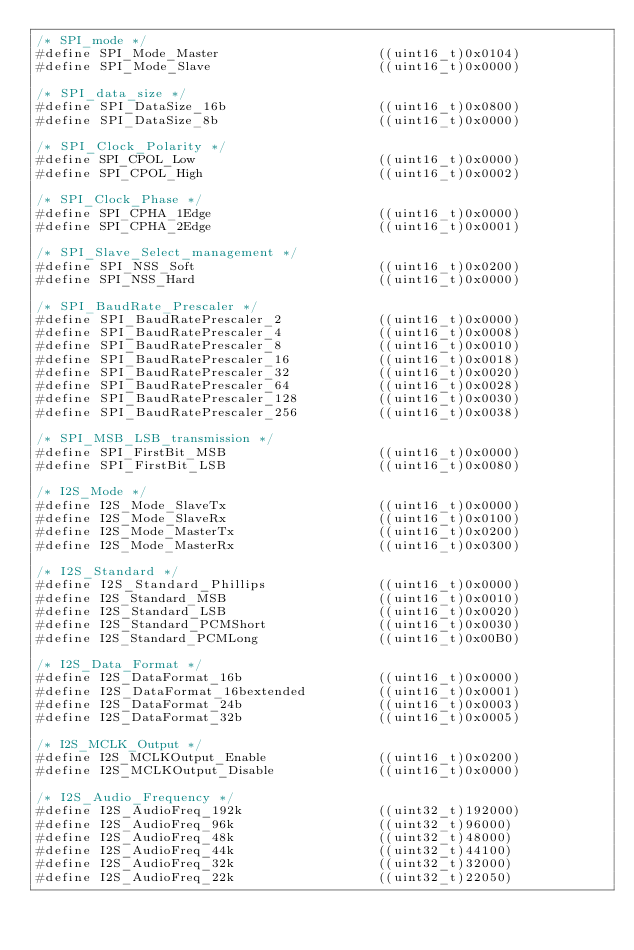<code> <loc_0><loc_0><loc_500><loc_500><_C_>/* SPI_mode */
#define SPI_Mode_Master                    ((uint16_t)0x0104)
#define SPI_Mode_Slave                     ((uint16_t)0x0000)

/* SPI_data_size */
#define SPI_DataSize_16b                   ((uint16_t)0x0800)
#define SPI_DataSize_8b                    ((uint16_t)0x0000)

/* SPI_Clock_Polarity */
#define SPI_CPOL_Low                       ((uint16_t)0x0000)
#define SPI_CPOL_High                      ((uint16_t)0x0002)

/* SPI_Clock_Phase */
#define SPI_CPHA_1Edge                     ((uint16_t)0x0000)
#define SPI_CPHA_2Edge                     ((uint16_t)0x0001)

/* SPI_Slave_Select_management */
#define SPI_NSS_Soft                       ((uint16_t)0x0200)
#define SPI_NSS_Hard                       ((uint16_t)0x0000)

/* SPI_BaudRate_Prescaler */
#define SPI_BaudRatePrescaler_2            ((uint16_t)0x0000)
#define SPI_BaudRatePrescaler_4            ((uint16_t)0x0008)
#define SPI_BaudRatePrescaler_8            ((uint16_t)0x0010)
#define SPI_BaudRatePrescaler_16           ((uint16_t)0x0018)
#define SPI_BaudRatePrescaler_32           ((uint16_t)0x0020)
#define SPI_BaudRatePrescaler_64           ((uint16_t)0x0028)
#define SPI_BaudRatePrescaler_128          ((uint16_t)0x0030)
#define SPI_BaudRatePrescaler_256          ((uint16_t)0x0038)

/* SPI_MSB_LSB_transmission */
#define SPI_FirstBit_MSB                   ((uint16_t)0x0000)
#define SPI_FirstBit_LSB                   ((uint16_t)0x0080)

/* I2S_Mode */
#define I2S_Mode_SlaveTx                   ((uint16_t)0x0000)
#define I2S_Mode_SlaveRx                   ((uint16_t)0x0100)
#define I2S_Mode_MasterTx                  ((uint16_t)0x0200)
#define I2S_Mode_MasterRx                  ((uint16_t)0x0300)

/* I2S_Standard */
#define I2S_Standard_Phillips              ((uint16_t)0x0000)
#define I2S_Standard_MSB                   ((uint16_t)0x0010)
#define I2S_Standard_LSB                   ((uint16_t)0x0020)
#define I2S_Standard_PCMShort              ((uint16_t)0x0030)
#define I2S_Standard_PCMLong               ((uint16_t)0x00B0)

/* I2S_Data_Format */
#define I2S_DataFormat_16b                 ((uint16_t)0x0000)
#define I2S_DataFormat_16bextended         ((uint16_t)0x0001)
#define I2S_DataFormat_24b                 ((uint16_t)0x0003)
#define I2S_DataFormat_32b                 ((uint16_t)0x0005)

/* I2S_MCLK_Output */
#define I2S_MCLKOutput_Enable              ((uint16_t)0x0200)
#define I2S_MCLKOutput_Disable             ((uint16_t)0x0000)

/* I2S_Audio_Frequency */
#define I2S_AudioFreq_192k                 ((uint32_t)192000)
#define I2S_AudioFreq_96k                  ((uint32_t)96000)
#define I2S_AudioFreq_48k                  ((uint32_t)48000)
#define I2S_AudioFreq_44k                  ((uint32_t)44100)
#define I2S_AudioFreq_32k                  ((uint32_t)32000)
#define I2S_AudioFreq_22k                  ((uint32_t)22050)</code> 